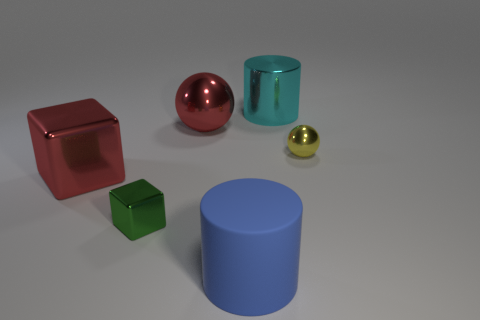Are there any big cylinders that have the same material as the green block?
Provide a succinct answer. Yes. There is a shiny ball that is the same color as the big shiny cube; what is its size?
Ensure brevity in your answer.  Large. How many cylinders are large blue things or cyan things?
Your answer should be compact. 2. Is the number of large matte objects that are right of the big cyan shiny cylinder greater than the number of red things in front of the large red cube?
Make the answer very short. No. What number of big spheres have the same color as the small metallic cube?
Provide a succinct answer. 0. What size is the red block that is the same material as the green object?
Provide a short and direct response. Large. What number of things are either big shiny cylinders right of the green shiny thing or green metal things?
Offer a very short reply. 2. There is a shiny block to the left of the green thing; does it have the same color as the big rubber cylinder?
Give a very brief answer. No. What is the size of the red object that is the same shape as the yellow metallic object?
Your response must be concise. Large. There is a metal sphere that is behind the tiny metallic thing on the right side of the blue object that is to the right of the large shiny ball; what color is it?
Your answer should be very brief. Red. 